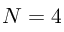<formula> <loc_0><loc_0><loc_500><loc_500>N = 4</formula> 